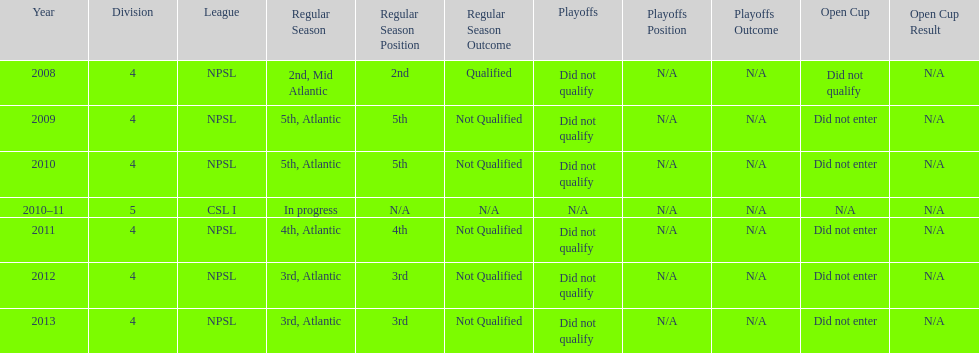What is the final year they managed to rank 3rd? 2013. 